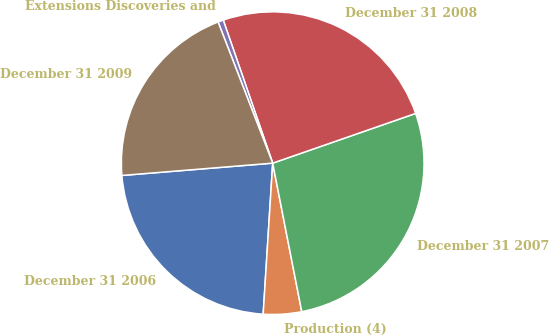Convert chart to OTSL. <chart><loc_0><loc_0><loc_500><loc_500><pie_chart><fcel>December 31 2006<fcel>Production (4)<fcel>December 31 2007<fcel>December 31 2008<fcel>Extensions Discoveries and<fcel>December 31 2009<nl><fcel>22.7%<fcel>4.08%<fcel>27.25%<fcel>24.97%<fcel>0.58%<fcel>20.42%<nl></chart> 